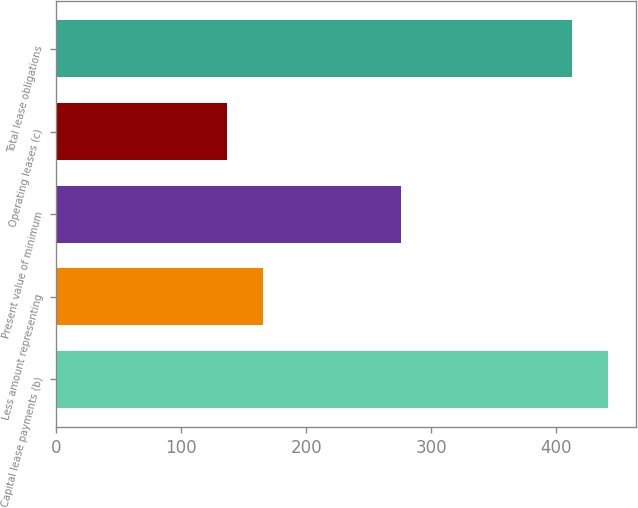<chart> <loc_0><loc_0><loc_500><loc_500><bar_chart><fcel>Capital lease payments (b)<fcel>Less amount representing<fcel>Present value of minimum<fcel>Operating leases (c)<fcel>Total lease obligations<nl><fcel>441.8<fcel>165.8<fcel>276<fcel>137<fcel>413<nl></chart> 